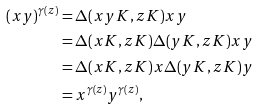<formula> <loc_0><loc_0><loc_500><loc_500>( x y ) ^ { \gamma ( z ) } & = \Delta ( x y K , z K ) x y \\ & = \Delta ( x K , z K ) \Delta ( y K , z K ) x y \\ & = \Delta ( x K , z K ) x \Delta ( y K , z K ) y \\ & = x ^ { \gamma ( z ) } y ^ { \gamma ( z ) } ,</formula> 